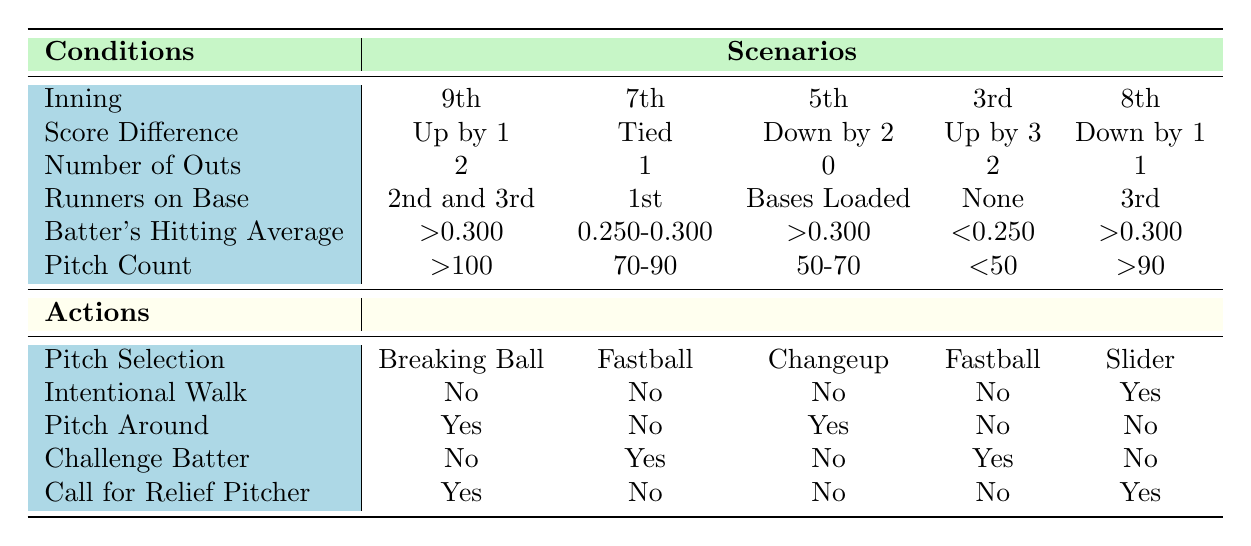What pitch selection is recommended in the 9th inning with a score difference of up by 1? According to the table, in the 9th inning when the score difference is up by 1, the recommended pitch selection is a Breaking Ball.
Answer: Breaking Ball What is the batter's hitting average in the 5th inning if the decision is to pitch around? The table states that in the 5th inning, if the decision is to pitch around, the batter's hitting average must be greater than 0.300.
Answer: >0.300 Is an intentional walk recommended in the 7th inning with the score tied and 1 out? The table shows that in the 7th inning with the score tied and 1 out, the recommendation is to not give an intentional walk.
Answer: No What is the total number of outs across all scenarios listed in the table? To find the total outs, we sum the outs in each scenario: 2 (9th) + 1 (7th) + 0 (5th) + 2 (3rd) + 1 (8th) = 6.
Answer: 6 In how many scenarios is it recommended to call for a relief pitcher? By examining the table, relief pitchers are called in the 9th inning and the 8th inning. Therefore, it is recommended in 2 scenarios.
Answer: 2 What is the recommended action when the batter's hitting average is below 0.250 and the team is ahead by 3 runs? The table indicates that if the batter's hitting average is below 0.250 and the team is up by 3 runs, the recommended action is to challenge the batter.
Answer: Challenge Batter Is it true that a changeup is recommended when there are bases loaded in the 5th inning? A review of the table confirms that a changeup is indeed the recommended pitch selection with bases loaded in the 5th inning.
Answer: Yes What are the recommended actions if the pitch count is greater than 90 in the 8th inning and there is 1 out? In this situation, the table indicates an intentional walk is suggested, as well as calling for a relief pitcher.
Answer: Intentional Walk and Call for Relief Pitcher What action is taken if there's a score difference of down by 1 in the 8th inning with a batter who has a hitting average above 0.300? The table shows that in this scenario, it is recommended to give an intentional walk and call for a relief pitcher.
Answer: Intentional Walk and Call for Relief Pitcher 